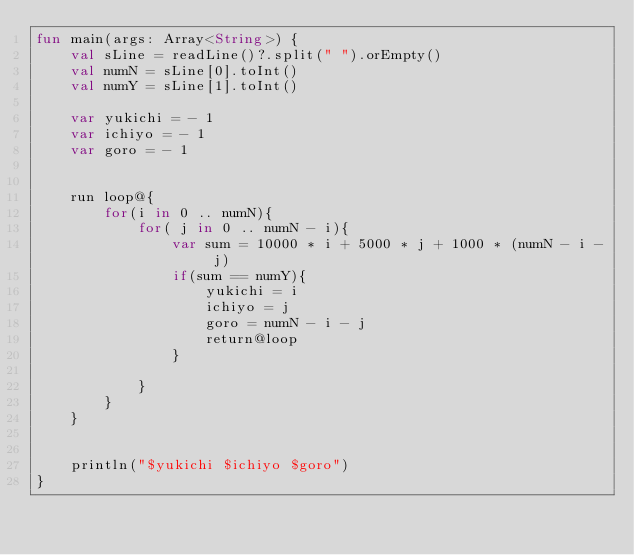Convert code to text. <code><loc_0><loc_0><loc_500><loc_500><_Kotlin_>fun main(args: Array<String>) {
    val sLine = readLine()?.split(" ").orEmpty()
    val numN = sLine[0].toInt()
    val numY = sLine[1].toInt()

    var yukichi = - 1
    var ichiyo = - 1
    var goro = - 1


    run loop@{
        for(i in 0 .. numN){
            for( j in 0 .. numN - i){
                var sum = 10000 * i + 5000 * j + 1000 * (numN - i - j)
                if(sum == numY){
                    yukichi = i
                    ichiyo = j
                    goro = numN - i - j
                    return@loop
                }

            }
        }
    }


    println("$yukichi $ichiyo $goro")
}</code> 